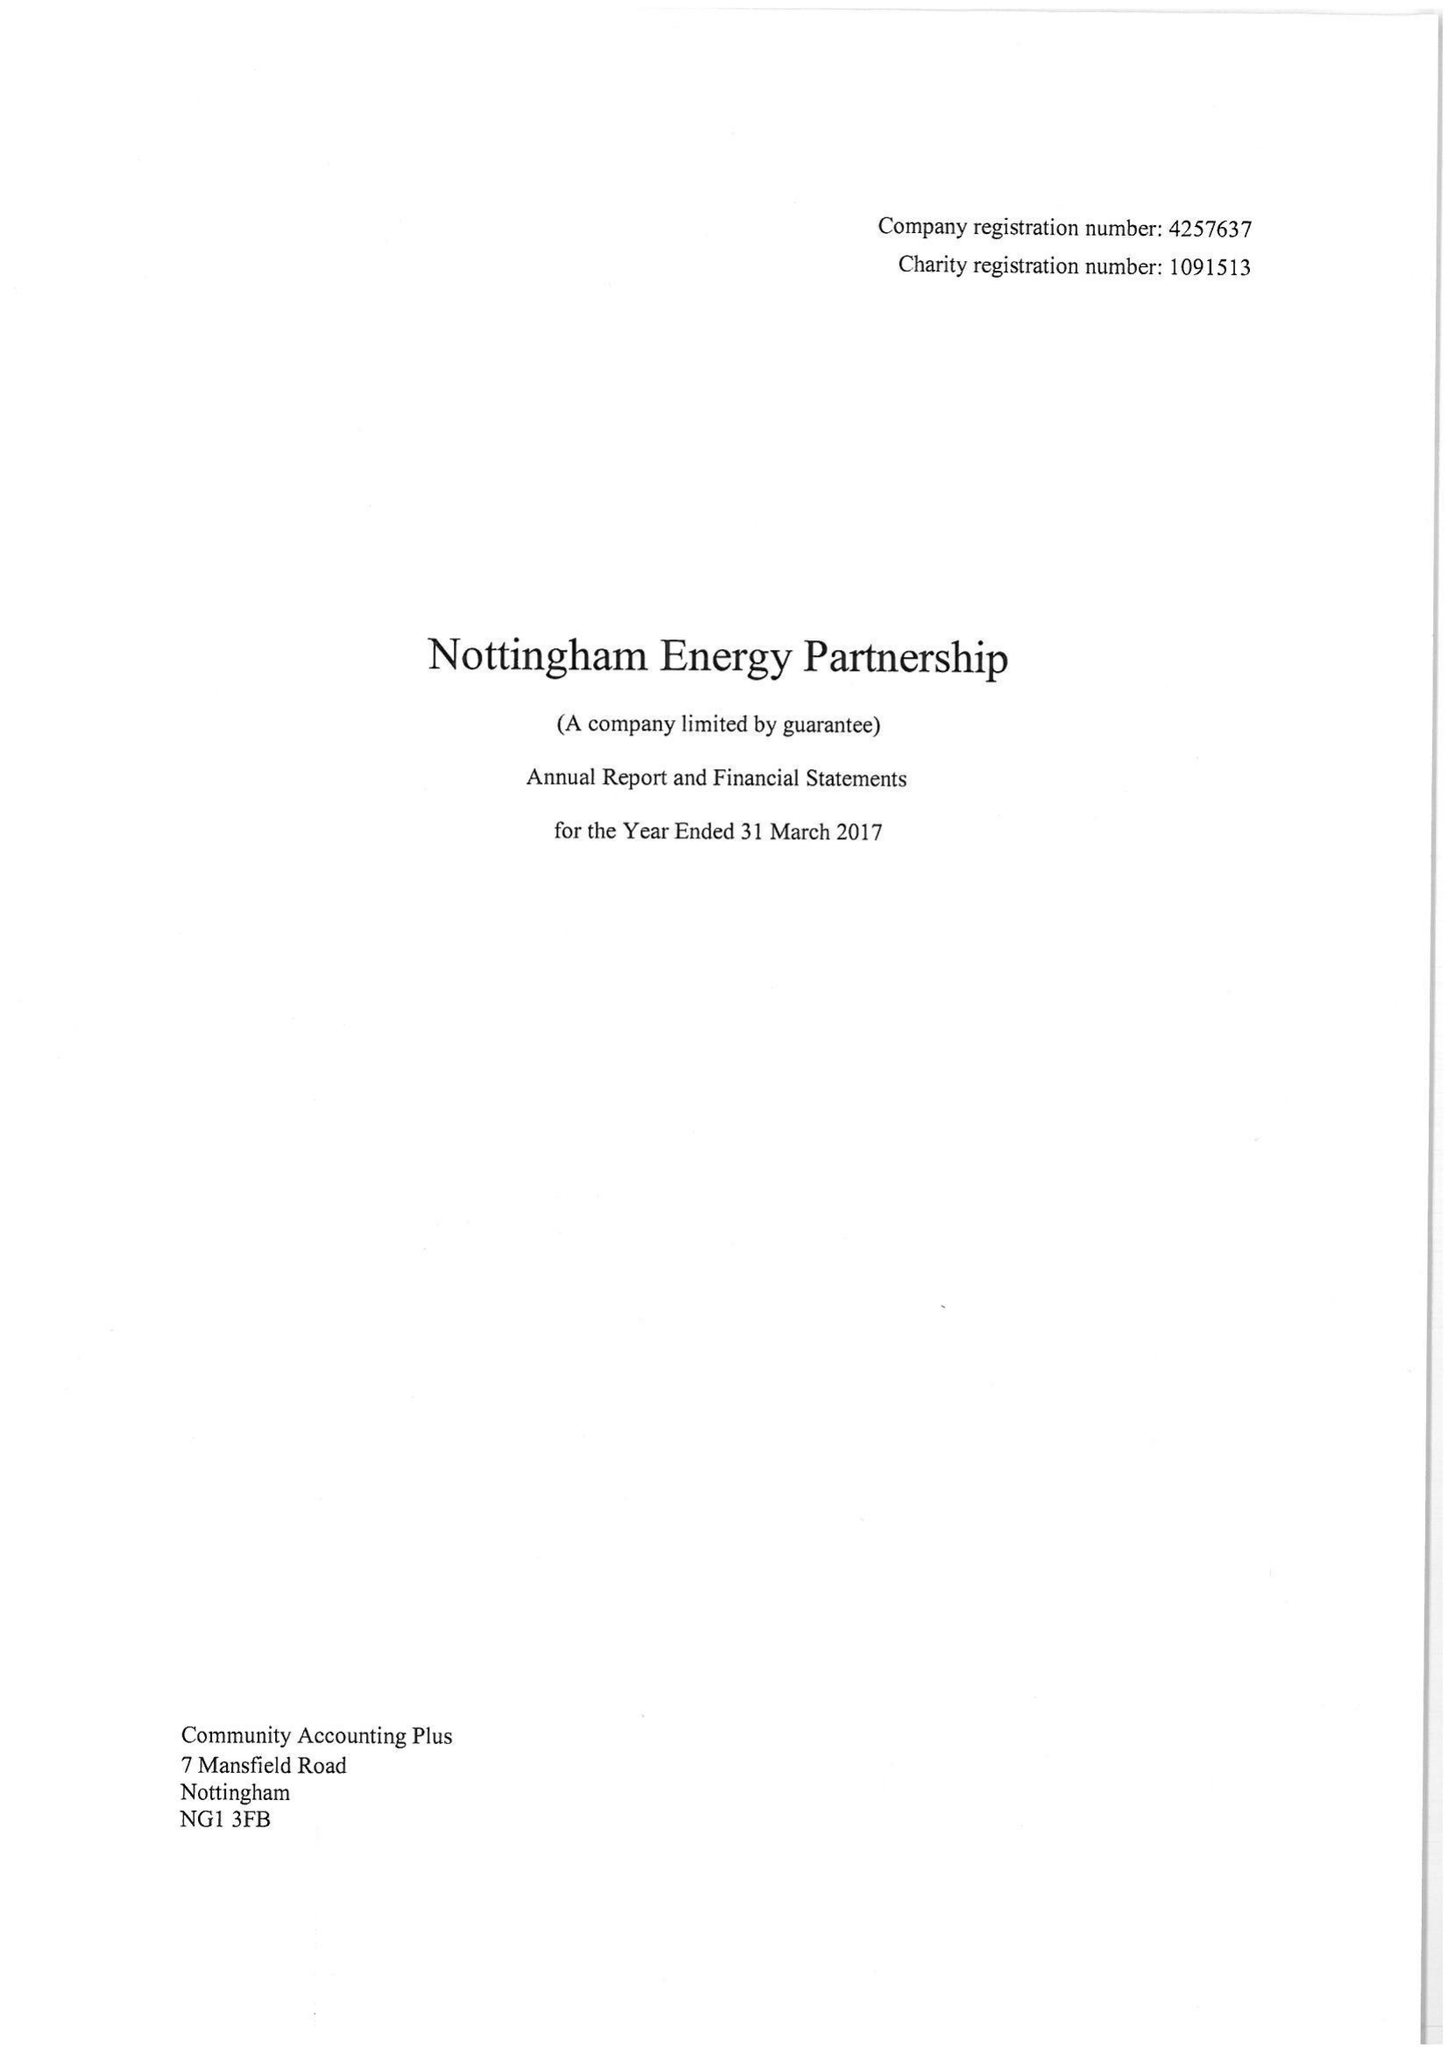What is the value for the address__street_line?
Answer the question using a single word or phrase. WATERWAY STREET 